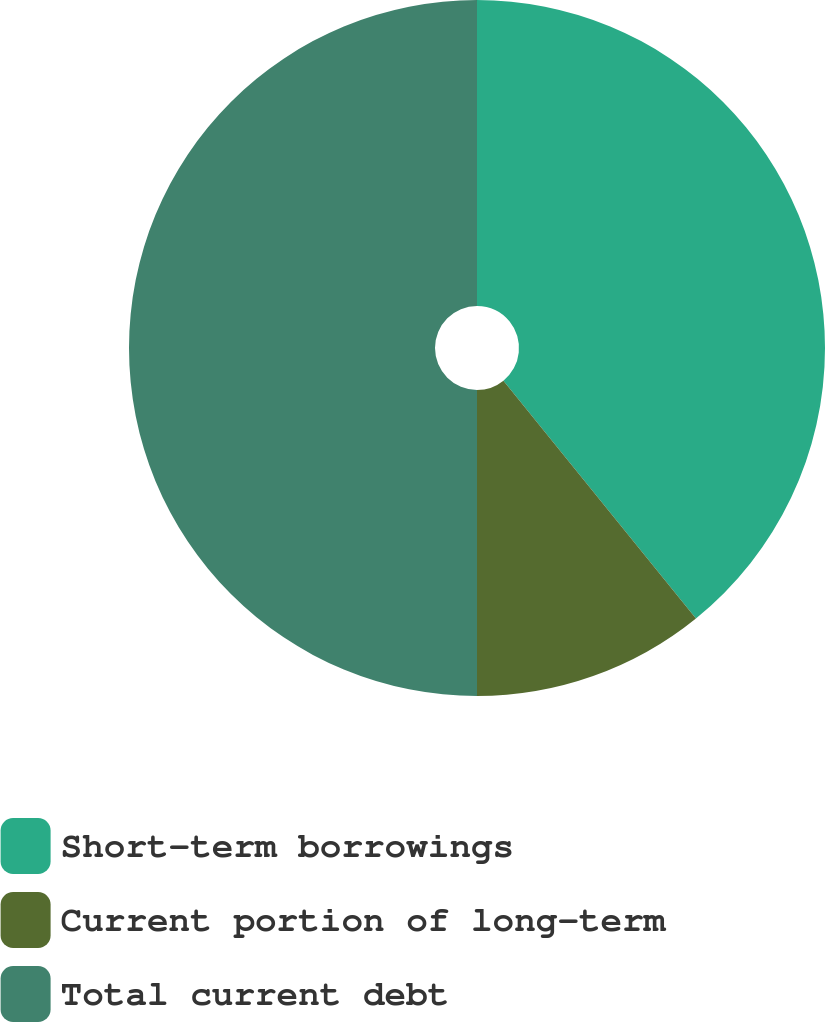Convert chart to OTSL. <chart><loc_0><loc_0><loc_500><loc_500><pie_chart><fcel>Short-term borrowings<fcel>Current portion of long-term<fcel>Total current debt<nl><fcel>39.17%<fcel>10.83%<fcel>50.0%<nl></chart> 